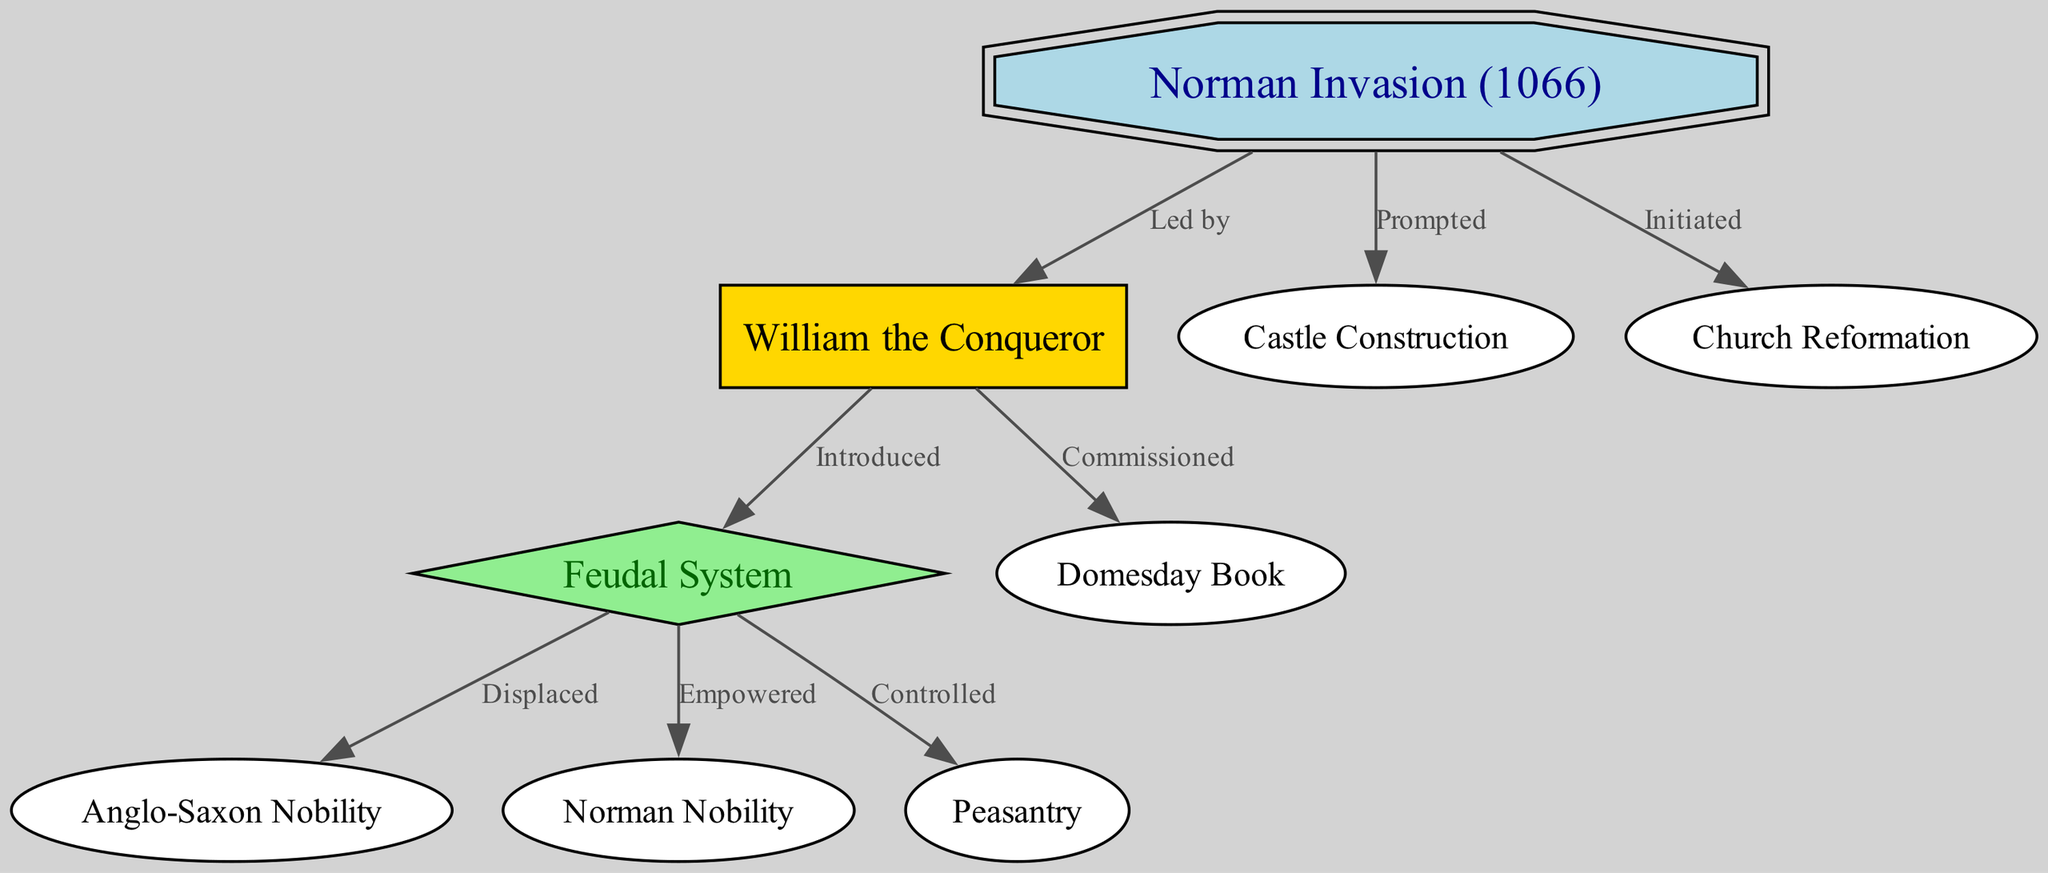What event is represented at the top of the diagram? The top of the diagram features the node "Norman Invasion (1066)," which indicates the key historical event that serves as the starting point for the relationships depicted in the directed graph.
Answer: Norman Invasion (1066) Who led the Norman Invasion? The diagram explicitly shows that the node "William the Conqueror" is connected to "Norman Invasion (1066)" with the label "Led by," identifying him as the leader of the invasion.
Answer: William the Conqueror How many edges connect to the Feudal System? Examining the diagram, the node "Feudal System" has three outgoing connections to "Anglo-Saxon Nobility," "Norman Nobility," and "Peasantry," which indicates it connects to three different nodes.
Answer: 3 What was commissioned by William the Conqueror? The directed graph shows an edge leading from "William the Conqueror" to "Domesday Book" with the label "Commissioned," indicating that he was responsible for its commissioning.
Answer: Domesday Book Which social group was displaced by the Feudal System? According to the diagram, there is an edge from "Feudal System" to "Anglo-Saxon Nobility" with the label "Displaced," directly identifying this group as affected by the system.
Answer: Anglo-Saxon Nobility What project was prompted by the Norman invasion? The diagram includes an edge from "Norman Invasion (1066)" to "Castle Construction" with the label "Prompted," which highlights that the invasion catalyzed this construction effort.
Answer: Castle Construction Which entity does the Feudal System control? There is a directed edge that leads from "Feudal System" to "Peasantry," marked with the label "Controlled," indicating that the Feudal System had control over this social group.
Answer: Peasantry What event initiated Church Reformation in the context of this diagram? The diagram connects "Norman Invasion (1066)" to "Church Reformation" with the label "Initiated," suggesting that the invasion set off the process of reform within the church.
Answer: Norman Invasion (1066) How does the directed graph organize the influence of the Norman invasion? The graph is structured in a hierarchy starting with the Norman Invasion at the top, leading down to various consequences and transformations in the British social structure, illustrating a direct flow of influence from the invasion to subsequent changes.
Answer: Hierarchical influence 